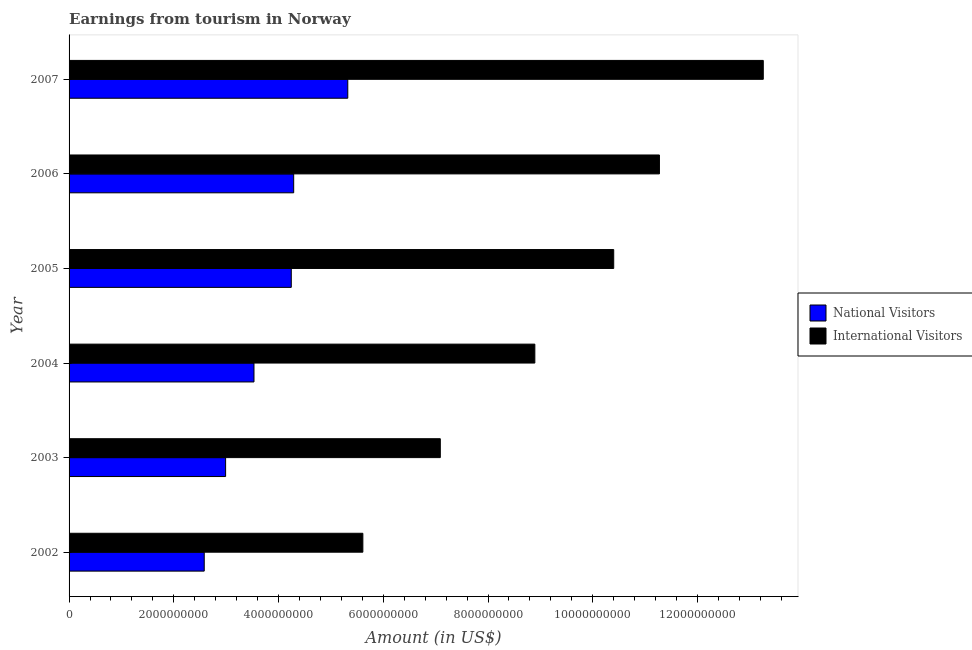How many groups of bars are there?
Provide a succinct answer. 6. How many bars are there on the 5th tick from the bottom?
Make the answer very short. 2. What is the label of the 5th group of bars from the top?
Ensure brevity in your answer.  2003. In how many cases, is the number of bars for a given year not equal to the number of legend labels?
Offer a very short reply. 0. What is the amount earned from international visitors in 2003?
Offer a very short reply. 7.09e+09. Across all years, what is the maximum amount earned from national visitors?
Provide a short and direct response. 5.32e+09. Across all years, what is the minimum amount earned from national visitors?
Provide a short and direct response. 2.58e+09. In which year was the amount earned from national visitors minimum?
Your answer should be compact. 2002. What is the total amount earned from international visitors in the graph?
Your answer should be compact. 5.65e+1. What is the difference between the amount earned from international visitors in 2006 and that in 2007?
Your answer should be very brief. -1.98e+09. What is the difference between the amount earned from international visitors in 2005 and the amount earned from national visitors in 2007?
Keep it short and to the point. 5.08e+09. What is the average amount earned from international visitors per year?
Provide a short and direct response. 9.42e+09. In the year 2006, what is the difference between the amount earned from international visitors and amount earned from national visitors?
Offer a very short reply. 6.98e+09. In how many years, is the amount earned from international visitors greater than 2000000000 US$?
Offer a very short reply. 6. What is the ratio of the amount earned from national visitors in 2006 to that in 2007?
Your response must be concise. 0.81. Is the amount earned from international visitors in 2002 less than that in 2007?
Provide a succinct answer. Yes. Is the difference between the amount earned from international visitors in 2006 and 2007 greater than the difference between the amount earned from national visitors in 2006 and 2007?
Give a very brief answer. No. What is the difference between the highest and the second highest amount earned from national visitors?
Provide a short and direct response. 1.03e+09. What is the difference between the highest and the lowest amount earned from international visitors?
Offer a very short reply. 7.65e+09. Is the sum of the amount earned from international visitors in 2004 and 2007 greater than the maximum amount earned from national visitors across all years?
Your answer should be compact. Yes. What does the 1st bar from the top in 2002 represents?
Offer a terse response. International Visitors. What does the 2nd bar from the bottom in 2007 represents?
Give a very brief answer. International Visitors. Are the values on the major ticks of X-axis written in scientific E-notation?
Offer a terse response. No. Does the graph contain any zero values?
Make the answer very short. No. Where does the legend appear in the graph?
Give a very brief answer. Center right. What is the title of the graph?
Ensure brevity in your answer.  Earnings from tourism in Norway. Does "Current education expenditure" appear as one of the legend labels in the graph?
Ensure brevity in your answer.  No. What is the label or title of the X-axis?
Make the answer very short. Amount (in US$). What is the Amount (in US$) of National Visitors in 2002?
Your response must be concise. 2.58e+09. What is the Amount (in US$) of International Visitors in 2002?
Offer a terse response. 5.61e+09. What is the Amount (in US$) in National Visitors in 2003?
Your response must be concise. 2.99e+09. What is the Amount (in US$) of International Visitors in 2003?
Keep it short and to the point. 7.09e+09. What is the Amount (in US$) of National Visitors in 2004?
Your answer should be compact. 3.53e+09. What is the Amount (in US$) in International Visitors in 2004?
Ensure brevity in your answer.  8.89e+09. What is the Amount (in US$) in National Visitors in 2005?
Your answer should be compact. 4.24e+09. What is the Amount (in US$) of International Visitors in 2005?
Your answer should be very brief. 1.04e+1. What is the Amount (in US$) in National Visitors in 2006?
Your answer should be very brief. 4.29e+09. What is the Amount (in US$) of International Visitors in 2006?
Provide a short and direct response. 1.13e+1. What is the Amount (in US$) of National Visitors in 2007?
Keep it short and to the point. 5.32e+09. What is the Amount (in US$) in International Visitors in 2007?
Provide a short and direct response. 1.33e+1. Across all years, what is the maximum Amount (in US$) of National Visitors?
Your response must be concise. 5.32e+09. Across all years, what is the maximum Amount (in US$) of International Visitors?
Give a very brief answer. 1.33e+1. Across all years, what is the minimum Amount (in US$) of National Visitors?
Your response must be concise. 2.58e+09. Across all years, what is the minimum Amount (in US$) in International Visitors?
Give a very brief answer. 5.61e+09. What is the total Amount (in US$) of National Visitors in the graph?
Keep it short and to the point. 2.30e+1. What is the total Amount (in US$) in International Visitors in the graph?
Make the answer very short. 5.65e+1. What is the difference between the Amount (in US$) in National Visitors in 2002 and that in 2003?
Offer a terse response. -4.08e+08. What is the difference between the Amount (in US$) of International Visitors in 2002 and that in 2003?
Your answer should be very brief. -1.48e+09. What is the difference between the Amount (in US$) of National Visitors in 2002 and that in 2004?
Your answer should be compact. -9.50e+08. What is the difference between the Amount (in US$) in International Visitors in 2002 and that in 2004?
Keep it short and to the point. -3.28e+09. What is the difference between the Amount (in US$) in National Visitors in 2002 and that in 2005?
Make the answer very short. -1.66e+09. What is the difference between the Amount (in US$) in International Visitors in 2002 and that in 2005?
Offer a very short reply. -4.79e+09. What is the difference between the Amount (in US$) of National Visitors in 2002 and that in 2006?
Make the answer very short. -1.71e+09. What is the difference between the Amount (in US$) of International Visitors in 2002 and that in 2006?
Offer a very short reply. -5.66e+09. What is the difference between the Amount (in US$) of National Visitors in 2002 and that in 2007?
Provide a succinct answer. -2.74e+09. What is the difference between the Amount (in US$) in International Visitors in 2002 and that in 2007?
Your answer should be very brief. -7.65e+09. What is the difference between the Amount (in US$) in National Visitors in 2003 and that in 2004?
Your response must be concise. -5.42e+08. What is the difference between the Amount (in US$) of International Visitors in 2003 and that in 2004?
Ensure brevity in your answer.  -1.80e+09. What is the difference between the Amount (in US$) in National Visitors in 2003 and that in 2005?
Give a very brief answer. -1.25e+09. What is the difference between the Amount (in US$) in International Visitors in 2003 and that in 2005?
Offer a very short reply. -3.31e+09. What is the difference between the Amount (in US$) of National Visitors in 2003 and that in 2006?
Your answer should be compact. -1.30e+09. What is the difference between the Amount (in US$) in International Visitors in 2003 and that in 2006?
Give a very brief answer. -4.18e+09. What is the difference between the Amount (in US$) of National Visitors in 2003 and that in 2007?
Ensure brevity in your answer.  -2.33e+09. What is the difference between the Amount (in US$) of International Visitors in 2003 and that in 2007?
Keep it short and to the point. -6.17e+09. What is the difference between the Amount (in US$) in National Visitors in 2004 and that in 2005?
Your answer should be very brief. -7.12e+08. What is the difference between the Amount (in US$) in International Visitors in 2004 and that in 2005?
Your answer should be very brief. -1.51e+09. What is the difference between the Amount (in US$) of National Visitors in 2004 and that in 2006?
Provide a succinct answer. -7.58e+08. What is the difference between the Amount (in US$) in International Visitors in 2004 and that in 2006?
Your answer should be compact. -2.38e+09. What is the difference between the Amount (in US$) of National Visitors in 2004 and that in 2007?
Your response must be concise. -1.79e+09. What is the difference between the Amount (in US$) in International Visitors in 2004 and that in 2007?
Your answer should be very brief. -4.36e+09. What is the difference between the Amount (in US$) of National Visitors in 2005 and that in 2006?
Your answer should be very brief. -4.60e+07. What is the difference between the Amount (in US$) in International Visitors in 2005 and that in 2006?
Your response must be concise. -8.73e+08. What is the difference between the Amount (in US$) of National Visitors in 2005 and that in 2007?
Offer a very short reply. -1.08e+09. What is the difference between the Amount (in US$) in International Visitors in 2005 and that in 2007?
Your answer should be compact. -2.86e+09. What is the difference between the Amount (in US$) of National Visitors in 2006 and that in 2007?
Your response must be concise. -1.03e+09. What is the difference between the Amount (in US$) of International Visitors in 2006 and that in 2007?
Your response must be concise. -1.98e+09. What is the difference between the Amount (in US$) of National Visitors in 2002 and the Amount (in US$) of International Visitors in 2003?
Ensure brevity in your answer.  -4.51e+09. What is the difference between the Amount (in US$) of National Visitors in 2002 and the Amount (in US$) of International Visitors in 2004?
Give a very brief answer. -6.31e+09. What is the difference between the Amount (in US$) of National Visitors in 2002 and the Amount (in US$) of International Visitors in 2005?
Give a very brief answer. -7.82e+09. What is the difference between the Amount (in US$) in National Visitors in 2002 and the Amount (in US$) in International Visitors in 2006?
Offer a terse response. -8.69e+09. What is the difference between the Amount (in US$) of National Visitors in 2002 and the Amount (in US$) of International Visitors in 2007?
Offer a very short reply. -1.07e+1. What is the difference between the Amount (in US$) in National Visitors in 2003 and the Amount (in US$) in International Visitors in 2004?
Offer a very short reply. -5.90e+09. What is the difference between the Amount (in US$) in National Visitors in 2003 and the Amount (in US$) in International Visitors in 2005?
Ensure brevity in your answer.  -7.41e+09. What is the difference between the Amount (in US$) in National Visitors in 2003 and the Amount (in US$) in International Visitors in 2006?
Keep it short and to the point. -8.28e+09. What is the difference between the Amount (in US$) of National Visitors in 2003 and the Amount (in US$) of International Visitors in 2007?
Provide a succinct answer. -1.03e+1. What is the difference between the Amount (in US$) in National Visitors in 2004 and the Amount (in US$) in International Visitors in 2005?
Keep it short and to the point. -6.87e+09. What is the difference between the Amount (in US$) of National Visitors in 2004 and the Amount (in US$) of International Visitors in 2006?
Your answer should be very brief. -7.74e+09. What is the difference between the Amount (in US$) in National Visitors in 2004 and the Amount (in US$) in International Visitors in 2007?
Your answer should be compact. -9.72e+09. What is the difference between the Amount (in US$) of National Visitors in 2005 and the Amount (in US$) of International Visitors in 2006?
Your answer should be very brief. -7.03e+09. What is the difference between the Amount (in US$) in National Visitors in 2005 and the Amount (in US$) in International Visitors in 2007?
Offer a very short reply. -9.01e+09. What is the difference between the Amount (in US$) in National Visitors in 2006 and the Amount (in US$) in International Visitors in 2007?
Your answer should be compact. -8.97e+09. What is the average Amount (in US$) of National Visitors per year?
Make the answer very short. 3.83e+09. What is the average Amount (in US$) in International Visitors per year?
Your response must be concise. 9.42e+09. In the year 2002, what is the difference between the Amount (in US$) in National Visitors and Amount (in US$) in International Visitors?
Provide a short and direct response. -3.03e+09. In the year 2003, what is the difference between the Amount (in US$) in National Visitors and Amount (in US$) in International Visitors?
Your response must be concise. -4.10e+09. In the year 2004, what is the difference between the Amount (in US$) in National Visitors and Amount (in US$) in International Visitors?
Make the answer very short. -5.36e+09. In the year 2005, what is the difference between the Amount (in US$) in National Visitors and Amount (in US$) in International Visitors?
Your answer should be very brief. -6.16e+09. In the year 2006, what is the difference between the Amount (in US$) of National Visitors and Amount (in US$) of International Visitors?
Offer a very short reply. -6.98e+09. In the year 2007, what is the difference between the Amount (in US$) of National Visitors and Amount (in US$) of International Visitors?
Offer a very short reply. -7.93e+09. What is the ratio of the Amount (in US$) in National Visitors in 2002 to that in 2003?
Ensure brevity in your answer.  0.86. What is the ratio of the Amount (in US$) of International Visitors in 2002 to that in 2003?
Your response must be concise. 0.79. What is the ratio of the Amount (in US$) of National Visitors in 2002 to that in 2004?
Your response must be concise. 0.73. What is the ratio of the Amount (in US$) of International Visitors in 2002 to that in 2004?
Provide a short and direct response. 0.63. What is the ratio of the Amount (in US$) of National Visitors in 2002 to that in 2005?
Your response must be concise. 0.61. What is the ratio of the Amount (in US$) in International Visitors in 2002 to that in 2005?
Keep it short and to the point. 0.54. What is the ratio of the Amount (in US$) of National Visitors in 2002 to that in 2006?
Your response must be concise. 0.6. What is the ratio of the Amount (in US$) in International Visitors in 2002 to that in 2006?
Your answer should be compact. 0.5. What is the ratio of the Amount (in US$) in National Visitors in 2002 to that in 2007?
Your answer should be compact. 0.48. What is the ratio of the Amount (in US$) in International Visitors in 2002 to that in 2007?
Your answer should be very brief. 0.42. What is the ratio of the Amount (in US$) in National Visitors in 2003 to that in 2004?
Keep it short and to the point. 0.85. What is the ratio of the Amount (in US$) of International Visitors in 2003 to that in 2004?
Offer a terse response. 0.8. What is the ratio of the Amount (in US$) of National Visitors in 2003 to that in 2005?
Your answer should be very brief. 0.7. What is the ratio of the Amount (in US$) of International Visitors in 2003 to that in 2005?
Make the answer very short. 0.68. What is the ratio of the Amount (in US$) in National Visitors in 2003 to that in 2006?
Your response must be concise. 0.7. What is the ratio of the Amount (in US$) of International Visitors in 2003 to that in 2006?
Your answer should be very brief. 0.63. What is the ratio of the Amount (in US$) in National Visitors in 2003 to that in 2007?
Offer a terse response. 0.56. What is the ratio of the Amount (in US$) of International Visitors in 2003 to that in 2007?
Your answer should be compact. 0.53. What is the ratio of the Amount (in US$) in National Visitors in 2004 to that in 2005?
Offer a very short reply. 0.83. What is the ratio of the Amount (in US$) of International Visitors in 2004 to that in 2005?
Your response must be concise. 0.86. What is the ratio of the Amount (in US$) of National Visitors in 2004 to that in 2006?
Offer a terse response. 0.82. What is the ratio of the Amount (in US$) in International Visitors in 2004 to that in 2006?
Keep it short and to the point. 0.79. What is the ratio of the Amount (in US$) of National Visitors in 2004 to that in 2007?
Give a very brief answer. 0.66. What is the ratio of the Amount (in US$) in International Visitors in 2004 to that in 2007?
Your response must be concise. 0.67. What is the ratio of the Amount (in US$) of National Visitors in 2005 to that in 2006?
Keep it short and to the point. 0.99. What is the ratio of the Amount (in US$) of International Visitors in 2005 to that in 2006?
Ensure brevity in your answer.  0.92. What is the ratio of the Amount (in US$) in National Visitors in 2005 to that in 2007?
Make the answer very short. 0.8. What is the ratio of the Amount (in US$) of International Visitors in 2005 to that in 2007?
Offer a very short reply. 0.78. What is the ratio of the Amount (in US$) in National Visitors in 2006 to that in 2007?
Ensure brevity in your answer.  0.81. What is the ratio of the Amount (in US$) of International Visitors in 2006 to that in 2007?
Give a very brief answer. 0.85. What is the difference between the highest and the second highest Amount (in US$) of National Visitors?
Offer a very short reply. 1.03e+09. What is the difference between the highest and the second highest Amount (in US$) of International Visitors?
Your answer should be very brief. 1.98e+09. What is the difference between the highest and the lowest Amount (in US$) in National Visitors?
Give a very brief answer. 2.74e+09. What is the difference between the highest and the lowest Amount (in US$) of International Visitors?
Offer a terse response. 7.65e+09. 